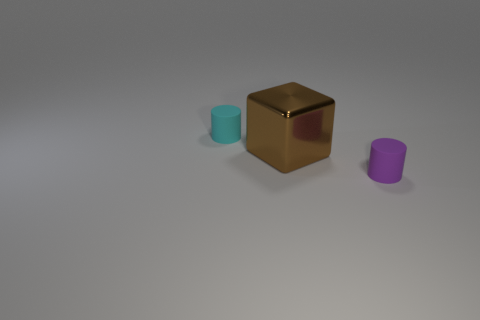What material is the other tiny thing that is the same shape as the tiny purple object?
Give a very brief answer. Rubber. What number of objects are tiny rubber objects in front of the large metal object or small things that are behind the brown shiny cube?
Provide a succinct answer. 2. There is a cube; is its color the same as the tiny cylinder that is to the right of the cyan matte object?
Keep it short and to the point. No. There is a small object that is the same material as the cyan cylinder; what shape is it?
Give a very brief answer. Cylinder. What number of small matte cylinders are there?
Give a very brief answer. 2. How many objects are small rubber things that are left of the tiny purple matte cylinder or brown cubes?
Your response must be concise. 2. Does the rubber object to the right of the large brown metallic object have the same color as the big metal block?
Provide a short and direct response. No. How many other things are there of the same color as the large object?
Your answer should be compact. 0. How many big objects are green rubber cylinders or metal blocks?
Make the answer very short. 1. Is the number of large cylinders greater than the number of tiny cyan matte things?
Offer a very short reply. No. 